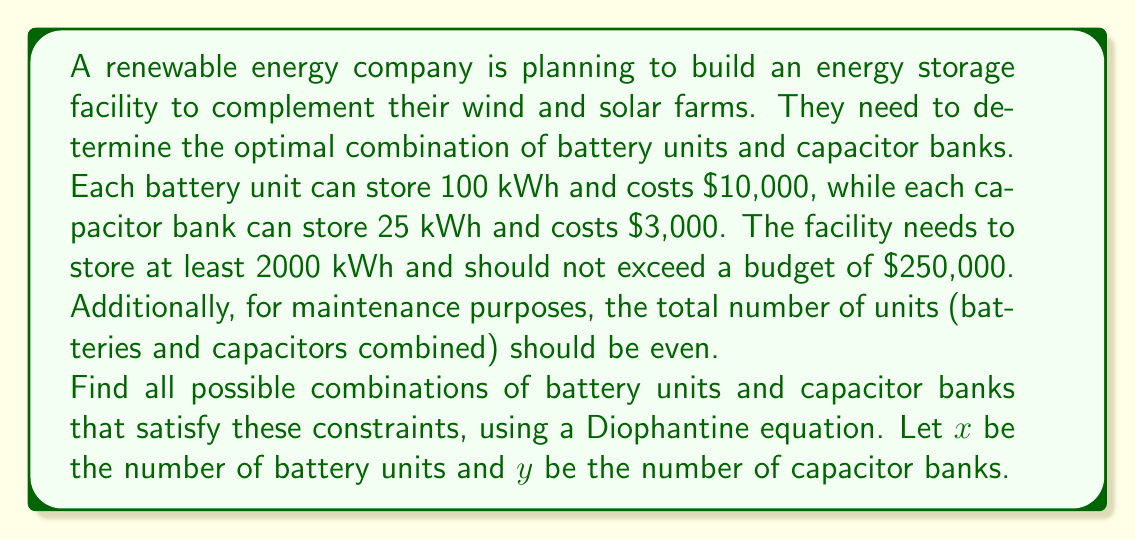What is the answer to this math problem? Let's approach this problem step by step:

1) First, we can formulate the storage capacity constraint:
   $$ 100x + 25y \geq 2000 $$

2) The budget constraint can be expressed as:
   $$ 10000x + 3000y \leq 250000 $$

3) The requirement for an even total number of units can be written as:
   $$ x + y = 2k $$
   where $k$ is some integer.

4) We can simplify the budget constraint by dividing by 1000:
   $$ 10x + 3y \leq 250 $$

5) Now, we need to solve these Diophantine equations and inequalities:
   $$ 100x + 25y \geq 2000 $$
   $$ 10x + 3y \leq 250 $$
   $$ x + y = 2k $$
   where $x$, $y$, and $k$ are non-negative integers.

6) From the storage capacity constraint, we can derive:
   $$ 4x + y \geq 80 $$

7) We can use the third equation to eliminate $y$:
   $$ y = 2k - x $$

8) Substituting this into the other two inequalities:
   $$ 4x + (2k - x) \geq 80 $$
   $$ 10x + 3(2k - x) \leq 250 $$

9) Simplifying:
   $$ 3x + 2k \geq 80 $$
   $$ 7x + 6k \leq 250 $$

10) We can now iterate through possible values of $k$ (starting from 40, as $x + y \geq 80$) and solve for $x$:

    For $k = 40$:
    $3x + 80 \geq 80$, so $x \geq 0$
    $7x + 240 \leq 250$, so $x \leq 1$
    $x$ must be even (as $y = 2k - x$ must be even)
    Therefore, $x = 0$ is the only solution for $k = 40$

    For $k = 41$:
    $3x + 82 \geq 80$, so $x \geq 0$
    $7x + 246 \leq 250$, so $x \leq 0$
    Therefore, $x = 0$ is the only solution for $k = 41$

    For $k \geq 42$, there are no solutions as the budget constraint would be violated.

11) The solutions are:
    For $k = 40$: $x = 0$, $y = 80$
    For $k = 41$: $x = 0$, $y = 82$

Therefore, there are two possible combinations:
1) 0 battery units and 80 capacitor banks
2) 0 battery units and 82 capacitor banks
Answer: The two possible combinations are:
1) 0 battery units and 80 capacitor banks
2) 0 battery units and 82 capacitor banks 